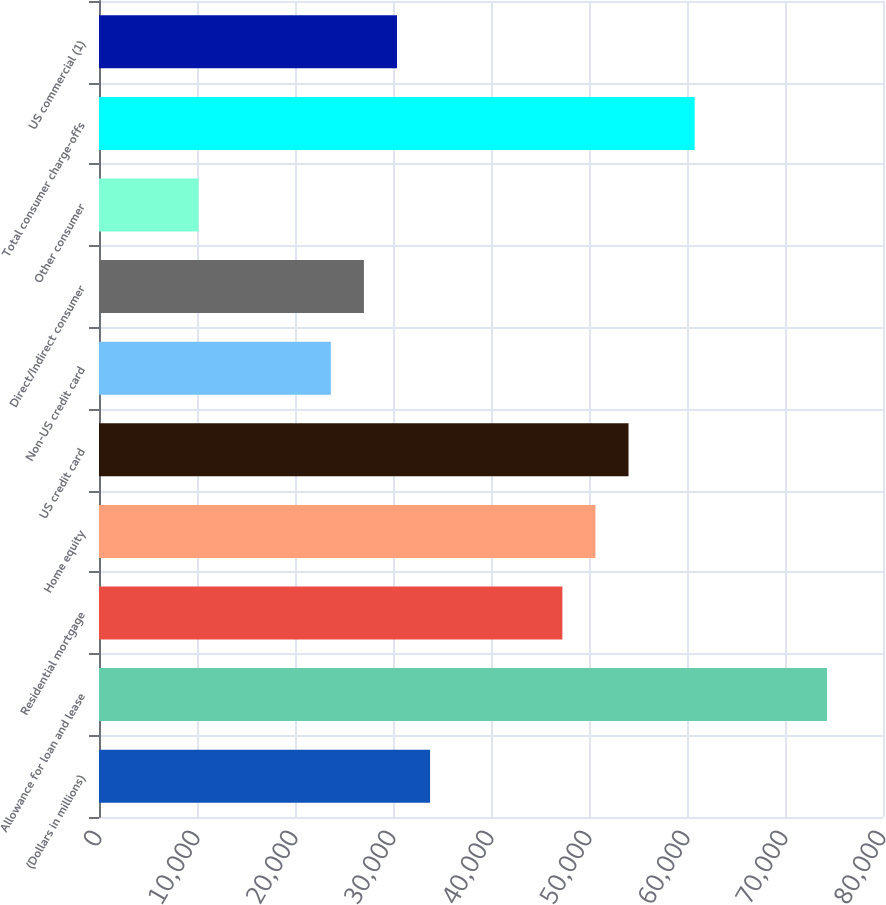<chart> <loc_0><loc_0><loc_500><loc_500><bar_chart><fcel>(Dollars in millions)<fcel>Allowance for loan and lease<fcel>Residential mortgage<fcel>Home equity<fcel>US credit card<fcel>Non-US credit card<fcel>Direct/Indirect consumer<fcel>Other consumer<fcel>Total consumer charge-offs<fcel>US commercial (1)<nl><fcel>33783<fcel>74284.2<fcel>47283.4<fcel>50658.5<fcel>54033.6<fcel>23657.7<fcel>27032.8<fcel>10157.3<fcel>60783.8<fcel>30407.9<nl></chart> 